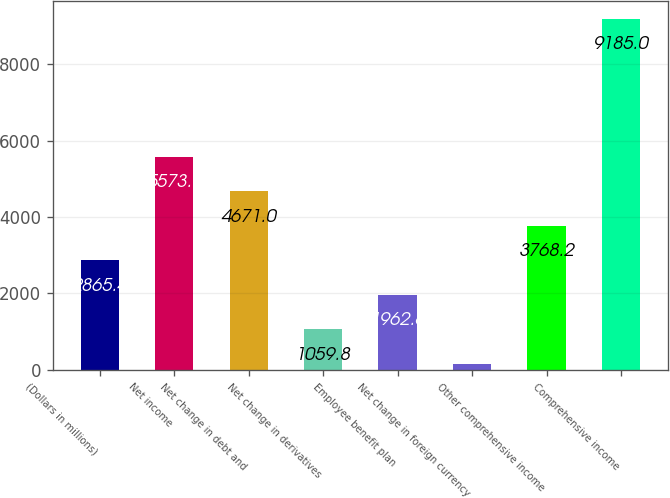<chart> <loc_0><loc_0><loc_500><loc_500><bar_chart><fcel>(Dollars in millions)<fcel>Net income<fcel>Net change in debt and<fcel>Net change in derivatives<fcel>Employee benefit plan<fcel>Net change in foreign currency<fcel>Other comprehensive income<fcel>Comprehensive income<nl><fcel>2865.4<fcel>5573.8<fcel>4671<fcel>1059.8<fcel>1962.6<fcel>157<fcel>3768.2<fcel>9185<nl></chart> 